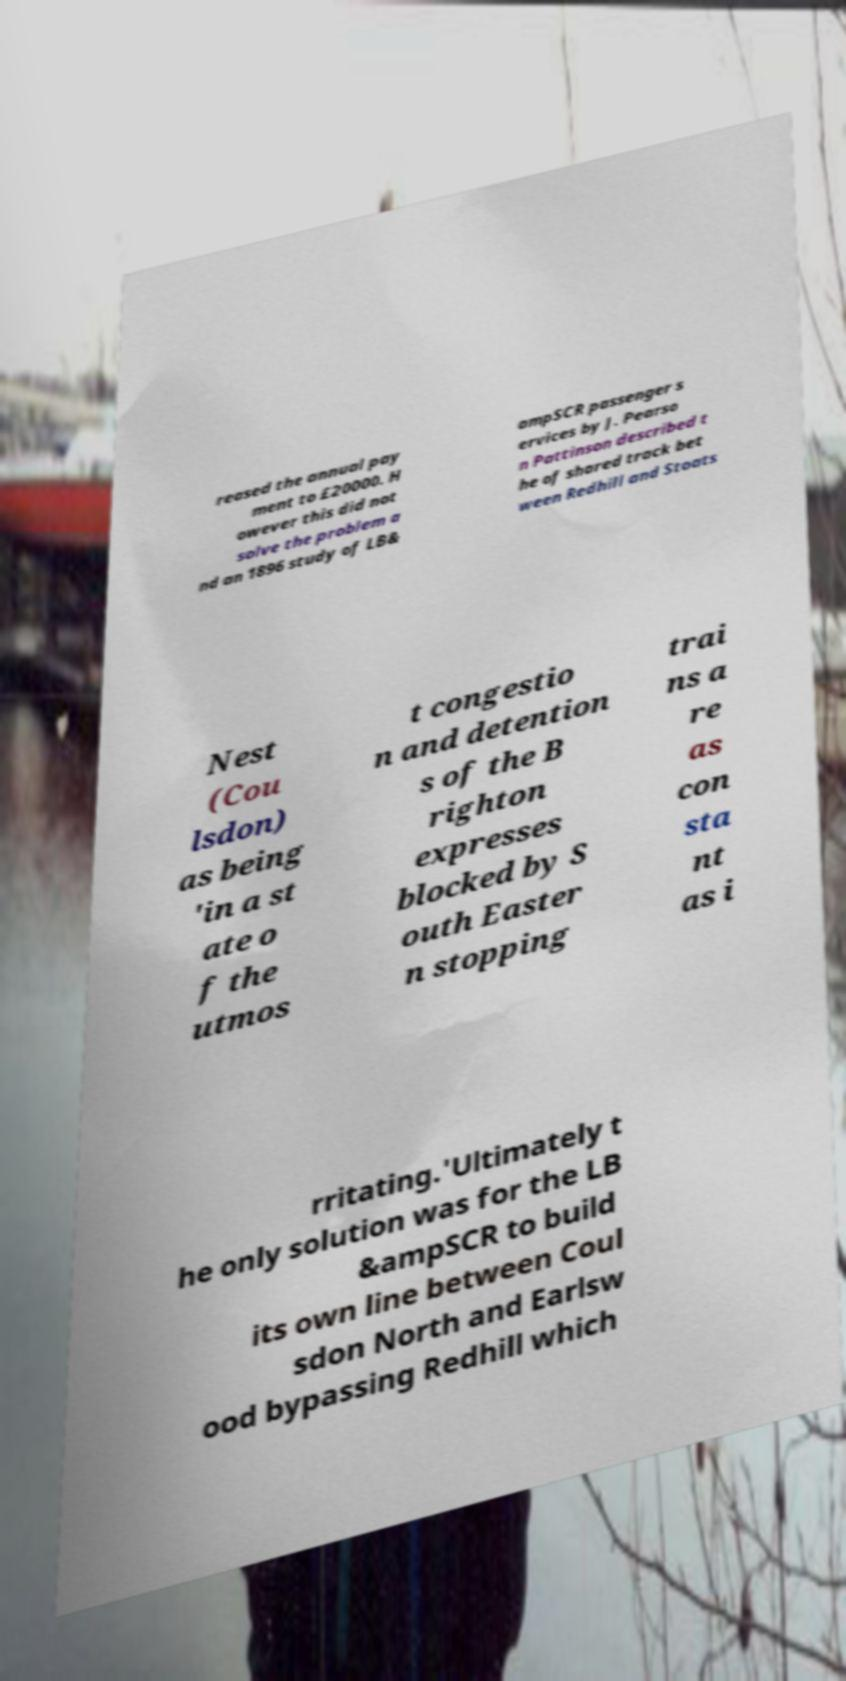Can you accurately transcribe the text from the provided image for me? reased the annual pay ment to £20000. H owever this did not solve the problem a nd an 1896 study of LB& ampSCR passenger s ervices by J. Pearso n Pattinson described t he of shared track bet ween Redhill and Stoats Nest (Cou lsdon) as being 'in a st ate o f the utmos t congestio n and detention s of the B righton expresses blocked by S outh Easter n stopping trai ns a re as con sta nt as i rritating.'Ultimately t he only solution was for the LB &ampSCR to build its own line between Coul sdon North and Earlsw ood bypassing Redhill which 